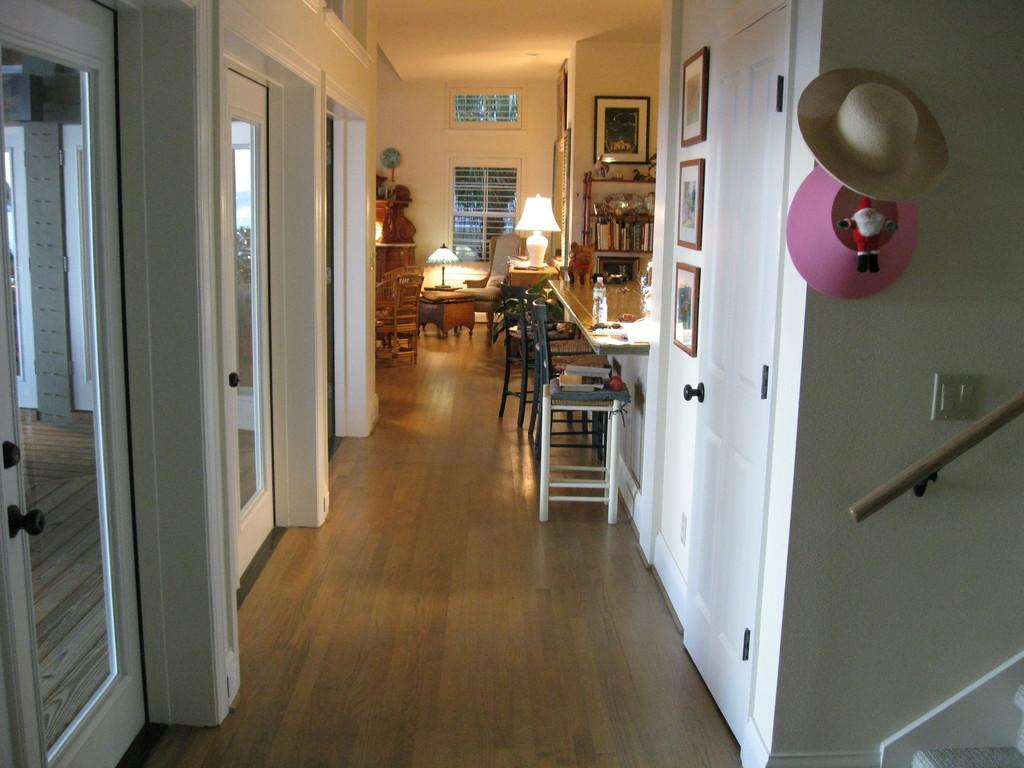What type of building is visible in the picture? There is a house in the picture. What type of furniture can be seen in the picture? There are tables, sofas, and chairs in the picture. What objects are in the backdrop of the picture? There are lamps and hats in the backdrop of the picture. What type of fruit is bursting in the picture? There is no fruit present in the picture, let alone one that is bursting. 